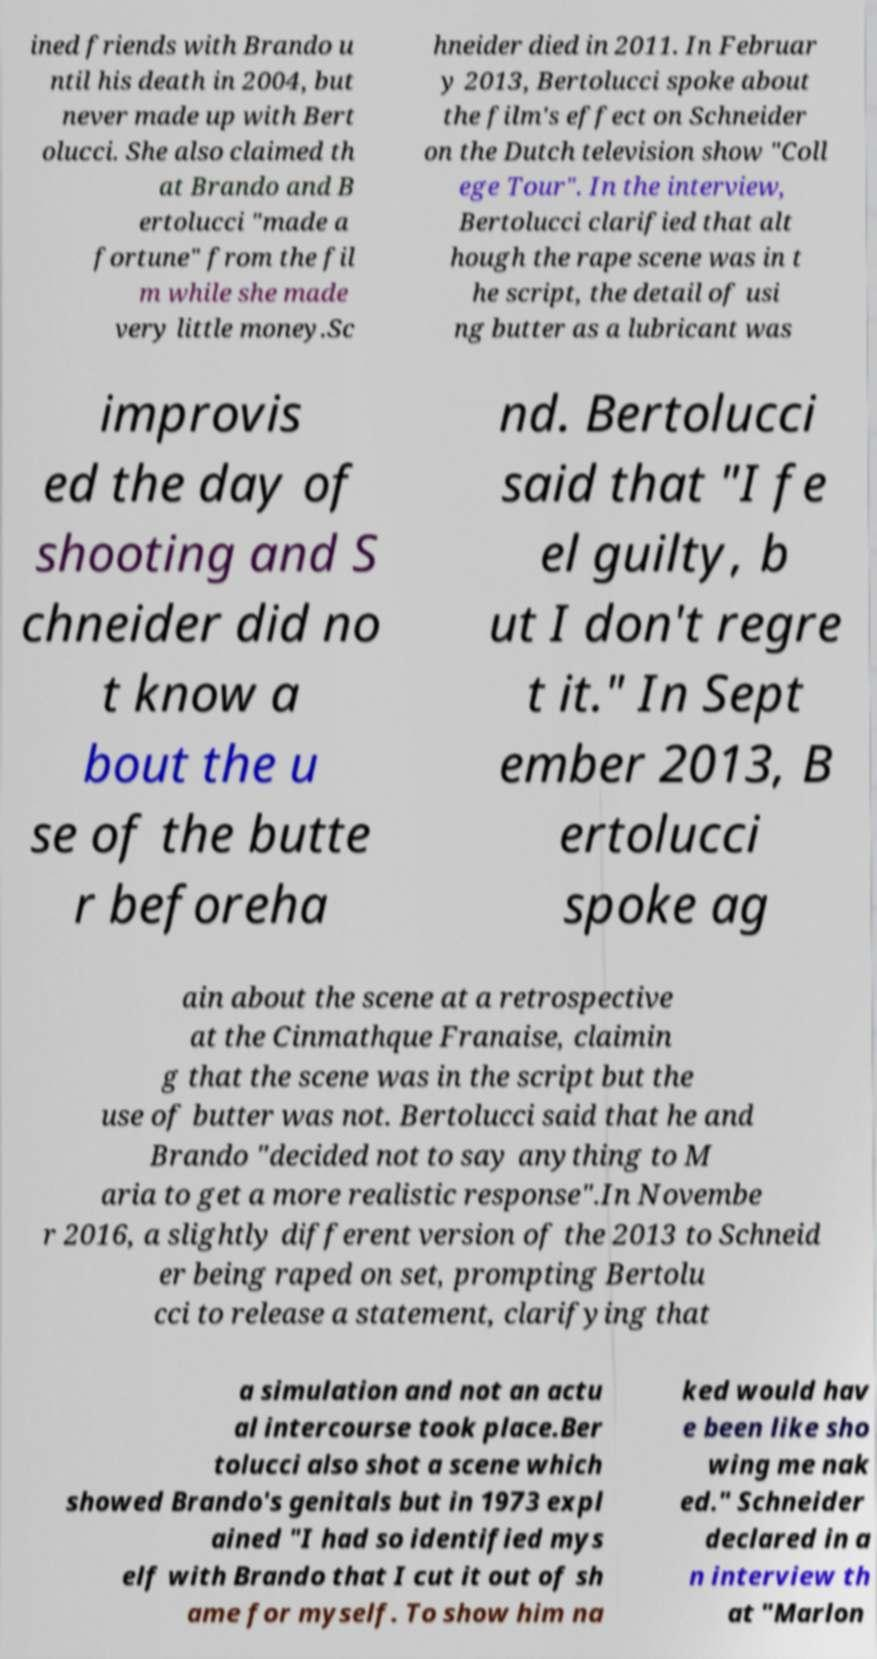Can you read and provide the text displayed in the image?This photo seems to have some interesting text. Can you extract and type it out for me? ined friends with Brando u ntil his death in 2004, but never made up with Bert olucci. She also claimed th at Brando and B ertolucci "made a fortune" from the fil m while she made very little money.Sc hneider died in 2011. In Februar y 2013, Bertolucci spoke about the film's effect on Schneider on the Dutch television show "Coll ege Tour". In the interview, Bertolucci clarified that alt hough the rape scene was in t he script, the detail of usi ng butter as a lubricant was improvis ed the day of shooting and S chneider did no t know a bout the u se of the butte r beforeha nd. Bertolucci said that "I fe el guilty, b ut I don't regre t it." In Sept ember 2013, B ertolucci spoke ag ain about the scene at a retrospective at the Cinmathque Franaise, claimin g that the scene was in the script but the use of butter was not. Bertolucci said that he and Brando "decided not to say anything to M aria to get a more realistic response".In Novembe r 2016, a slightly different version of the 2013 to Schneid er being raped on set, prompting Bertolu cci to release a statement, clarifying that a simulation and not an actu al intercourse took place.Ber tolucci also shot a scene which showed Brando's genitals but in 1973 expl ained "I had so identified mys elf with Brando that I cut it out of sh ame for myself. To show him na ked would hav e been like sho wing me nak ed." Schneider declared in a n interview th at "Marlon 